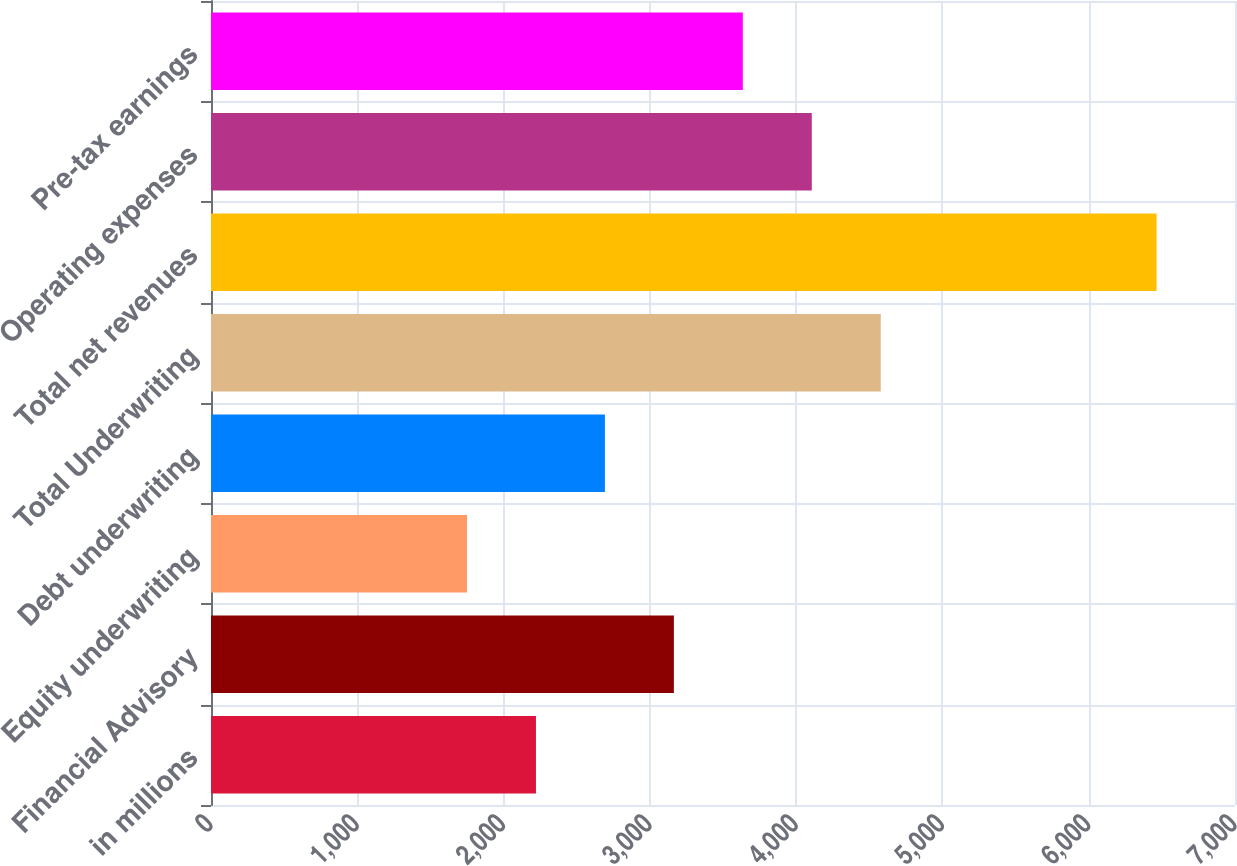Convert chart to OTSL. <chart><loc_0><loc_0><loc_500><loc_500><bar_chart><fcel>in millions<fcel>Financial Advisory<fcel>Equity underwriting<fcel>Debt underwriting<fcel>Total Underwriting<fcel>Total net revenues<fcel>Operating expenses<fcel>Pre-tax earnings<nl><fcel>2221.4<fcel>3164.2<fcel>1750<fcel>2692.8<fcel>4578.4<fcel>6464<fcel>4107<fcel>3635.6<nl></chart> 